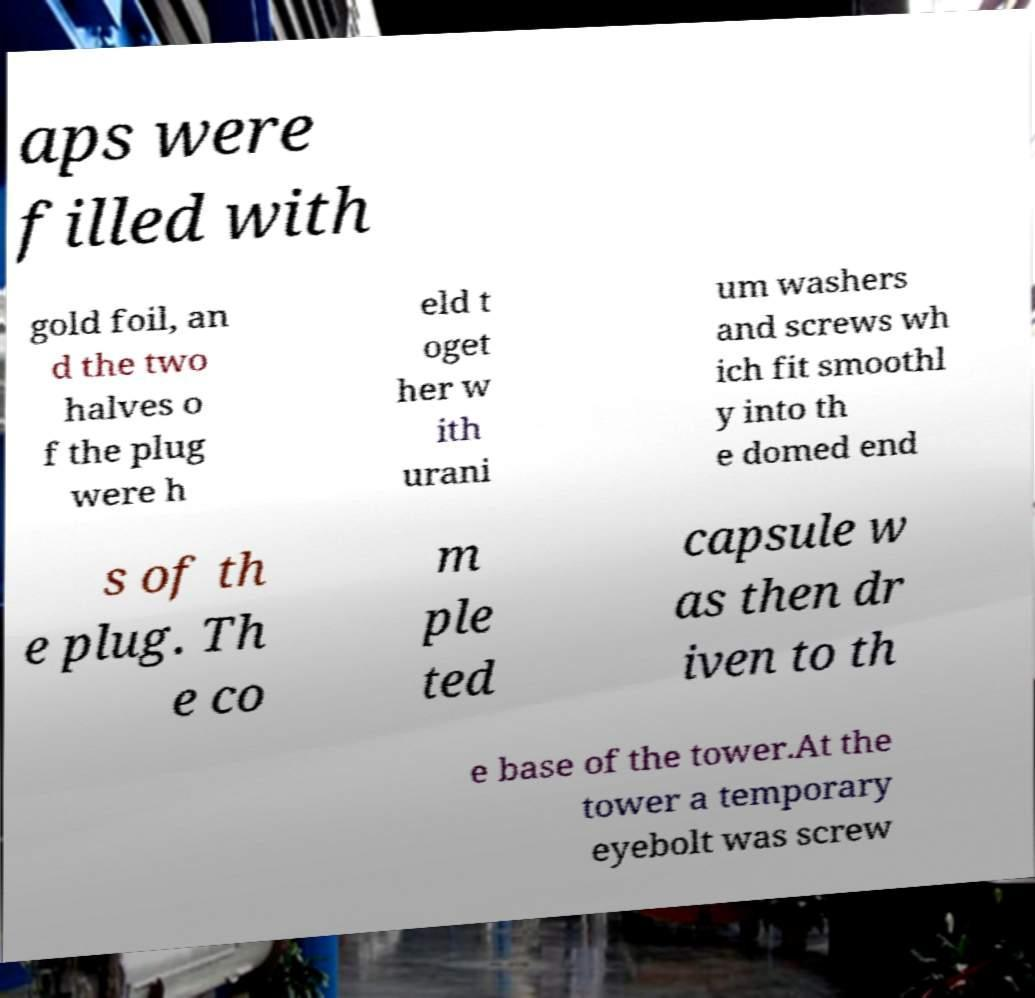Could you assist in decoding the text presented in this image and type it out clearly? aps were filled with gold foil, an d the two halves o f the plug were h eld t oget her w ith urani um washers and screws wh ich fit smoothl y into th e domed end s of th e plug. Th e co m ple ted capsule w as then dr iven to th e base of the tower.At the tower a temporary eyebolt was screw 